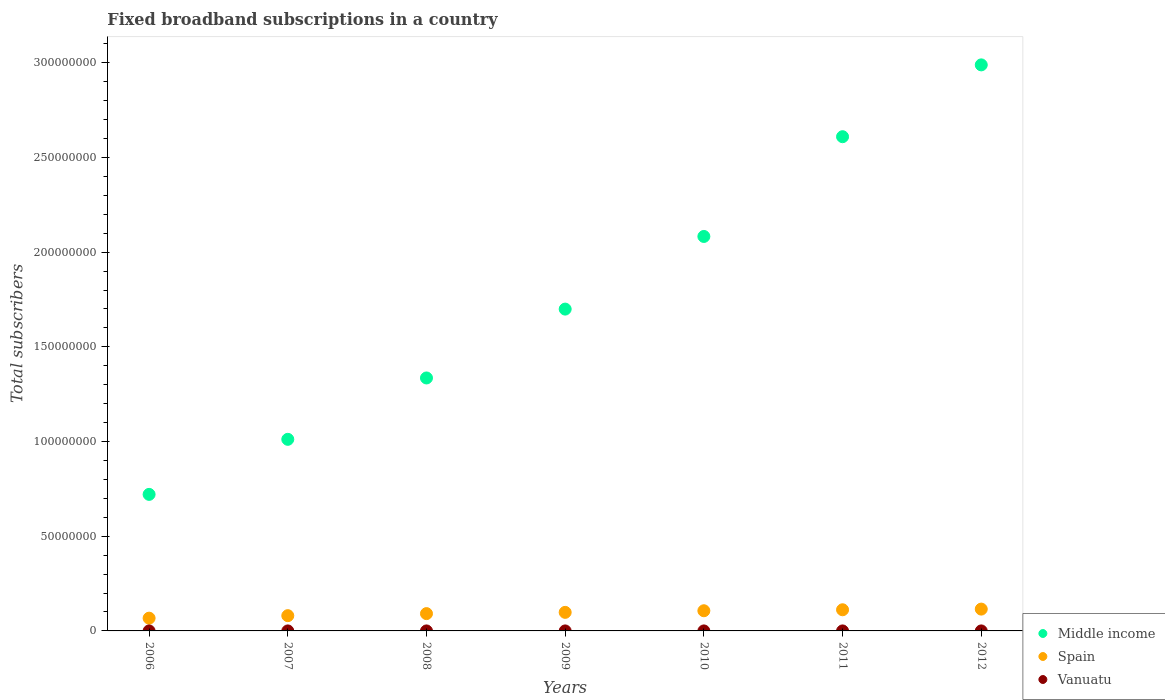How many different coloured dotlines are there?
Keep it short and to the point. 3. Is the number of dotlines equal to the number of legend labels?
Provide a succinct answer. Yes. What is the number of broadband subscriptions in Spain in 2010?
Your answer should be very brief. 1.07e+07. Across all years, what is the maximum number of broadband subscriptions in Middle income?
Make the answer very short. 2.99e+08. Across all years, what is the minimum number of broadband subscriptions in Spain?
Your answer should be compact. 6.74e+06. What is the total number of broadband subscriptions in Vanuatu in the graph?
Provide a succinct answer. 2072. What is the difference between the number of broadband subscriptions in Vanuatu in 2008 and that in 2009?
Give a very brief answer. -300. What is the difference between the number of broadband subscriptions in Spain in 2008 and the number of broadband subscriptions in Vanuatu in 2009?
Your response must be concise. 9.14e+06. What is the average number of broadband subscriptions in Vanuatu per year?
Ensure brevity in your answer.  296. In the year 2011, what is the difference between the number of broadband subscriptions in Spain and number of broadband subscriptions in Vanuatu?
Give a very brief answer. 1.12e+07. In how many years, is the number of broadband subscriptions in Middle income greater than 150000000?
Make the answer very short. 4. What is the ratio of the number of broadband subscriptions in Spain in 2006 to that in 2009?
Provide a succinct answer. 0.69. Is the number of broadband subscriptions in Middle income in 2007 less than that in 2009?
Offer a very short reply. Yes. Is the difference between the number of broadband subscriptions in Spain in 2008 and 2009 greater than the difference between the number of broadband subscriptions in Vanuatu in 2008 and 2009?
Your answer should be compact. No. What is the difference between the highest and the second highest number of broadband subscriptions in Vanuatu?
Make the answer very short. 0. What is the difference between the highest and the lowest number of broadband subscriptions in Middle income?
Keep it short and to the point. 2.27e+08. Is the sum of the number of broadband subscriptions in Vanuatu in 2007 and 2011 greater than the maximum number of broadband subscriptions in Middle income across all years?
Make the answer very short. No. Does the number of broadband subscriptions in Middle income monotonically increase over the years?
Your answer should be very brief. Yes. Is the number of broadband subscriptions in Middle income strictly greater than the number of broadband subscriptions in Spain over the years?
Your response must be concise. Yes. Is the number of broadband subscriptions in Spain strictly less than the number of broadband subscriptions in Middle income over the years?
Offer a terse response. Yes. Are the values on the major ticks of Y-axis written in scientific E-notation?
Your answer should be compact. No. Does the graph contain any zero values?
Your response must be concise. No. How are the legend labels stacked?
Offer a very short reply. Vertical. What is the title of the graph?
Provide a succinct answer. Fixed broadband subscriptions in a country. What is the label or title of the Y-axis?
Offer a terse response. Total subscribers. What is the Total subscribers in Middle income in 2006?
Keep it short and to the point. 7.21e+07. What is the Total subscribers in Spain in 2006?
Your answer should be compact. 6.74e+06. What is the Total subscribers in Vanuatu in 2006?
Keep it short and to the point. 95. What is the Total subscribers of Middle income in 2007?
Your answer should be very brief. 1.01e+08. What is the Total subscribers in Spain in 2007?
Your answer should be compact. 8.06e+06. What is the Total subscribers in Vanuatu in 2007?
Make the answer very short. 130. What is the Total subscribers of Middle income in 2008?
Your response must be concise. 1.34e+08. What is the Total subscribers in Spain in 2008?
Offer a terse response. 9.14e+06. What is the Total subscribers of Vanuatu in 2008?
Ensure brevity in your answer.  200. What is the Total subscribers in Middle income in 2009?
Keep it short and to the point. 1.70e+08. What is the Total subscribers in Spain in 2009?
Your answer should be compact. 9.80e+06. What is the Total subscribers in Middle income in 2010?
Offer a very short reply. 2.08e+08. What is the Total subscribers of Spain in 2010?
Provide a short and direct response. 1.07e+07. What is the Total subscribers in Middle income in 2011?
Offer a terse response. 2.61e+08. What is the Total subscribers of Spain in 2011?
Keep it short and to the point. 1.12e+07. What is the Total subscribers in Vanuatu in 2011?
Make the answer very short. 337. What is the Total subscribers of Middle income in 2012?
Offer a very short reply. 2.99e+08. What is the Total subscribers in Spain in 2012?
Offer a terse response. 1.15e+07. What is the Total subscribers in Vanuatu in 2012?
Offer a terse response. 310. Across all years, what is the maximum Total subscribers of Middle income?
Make the answer very short. 2.99e+08. Across all years, what is the maximum Total subscribers of Spain?
Your response must be concise. 1.15e+07. Across all years, what is the maximum Total subscribers of Vanuatu?
Offer a terse response. 500. Across all years, what is the minimum Total subscribers of Middle income?
Keep it short and to the point. 7.21e+07. Across all years, what is the minimum Total subscribers in Spain?
Ensure brevity in your answer.  6.74e+06. What is the total Total subscribers in Middle income in the graph?
Provide a short and direct response. 1.24e+09. What is the total Total subscribers in Spain in the graph?
Your response must be concise. 6.71e+07. What is the total Total subscribers of Vanuatu in the graph?
Offer a very short reply. 2072. What is the difference between the Total subscribers in Middle income in 2006 and that in 2007?
Offer a terse response. -2.91e+07. What is the difference between the Total subscribers in Spain in 2006 and that in 2007?
Keep it short and to the point. -1.32e+06. What is the difference between the Total subscribers of Vanuatu in 2006 and that in 2007?
Your answer should be very brief. -35. What is the difference between the Total subscribers in Middle income in 2006 and that in 2008?
Ensure brevity in your answer.  -6.15e+07. What is the difference between the Total subscribers of Spain in 2006 and that in 2008?
Your answer should be very brief. -2.40e+06. What is the difference between the Total subscribers of Vanuatu in 2006 and that in 2008?
Make the answer very short. -105. What is the difference between the Total subscribers of Middle income in 2006 and that in 2009?
Keep it short and to the point. -9.78e+07. What is the difference between the Total subscribers of Spain in 2006 and that in 2009?
Provide a succinct answer. -3.06e+06. What is the difference between the Total subscribers of Vanuatu in 2006 and that in 2009?
Offer a very short reply. -405. What is the difference between the Total subscribers in Middle income in 2006 and that in 2010?
Your answer should be compact. -1.36e+08. What is the difference between the Total subscribers in Spain in 2006 and that in 2010?
Make the answer very short. -3.91e+06. What is the difference between the Total subscribers in Vanuatu in 2006 and that in 2010?
Give a very brief answer. -405. What is the difference between the Total subscribers of Middle income in 2006 and that in 2011?
Keep it short and to the point. -1.89e+08. What is the difference between the Total subscribers of Spain in 2006 and that in 2011?
Your answer should be compact. -4.43e+06. What is the difference between the Total subscribers of Vanuatu in 2006 and that in 2011?
Your response must be concise. -242. What is the difference between the Total subscribers of Middle income in 2006 and that in 2012?
Your response must be concise. -2.27e+08. What is the difference between the Total subscribers in Spain in 2006 and that in 2012?
Offer a very short reply. -4.79e+06. What is the difference between the Total subscribers in Vanuatu in 2006 and that in 2012?
Offer a very short reply. -215. What is the difference between the Total subscribers in Middle income in 2007 and that in 2008?
Make the answer very short. -3.24e+07. What is the difference between the Total subscribers of Spain in 2007 and that in 2008?
Your response must be concise. -1.08e+06. What is the difference between the Total subscribers of Vanuatu in 2007 and that in 2008?
Your answer should be compact. -70. What is the difference between the Total subscribers of Middle income in 2007 and that in 2009?
Offer a very short reply. -6.88e+07. What is the difference between the Total subscribers of Spain in 2007 and that in 2009?
Provide a short and direct response. -1.74e+06. What is the difference between the Total subscribers of Vanuatu in 2007 and that in 2009?
Offer a very short reply. -370. What is the difference between the Total subscribers of Middle income in 2007 and that in 2010?
Provide a succinct answer. -1.07e+08. What is the difference between the Total subscribers of Spain in 2007 and that in 2010?
Provide a short and direct response. -2.60e+06. What is the difference between the Total subscribers in Vanuatu in 2007 and that in 2010?
Your answer should be very brief. -370. What is the difference between the Total subscribers of Middle income in 2007 and that in 2011?
Ensure brevity in your answer.  -1.60e+08. What is the difference between the Total subscribers of Spain in 2007 and that in 2011?
Provide a short and direct response. -3.11e+06. What is the difference between the Total subscribers in Vanuatu in 2007 and that in 2011?
Make the answer very short. -207. What is the difference between the Total subscribers in Middle income in 2007 and that in 2012?
Offer a very short reply. -1.98e+08. What is the difference between the Total subscribers in Spain in 2007 and that in 2012?
Your response must be concise. -3.47e+06. What is the difference between the Total subscribers in Vanuatu in 2007 and that in 2012?
Offer a terse response. -180. What is the difference between the Total subscribers of Middle income in 2008 and that in 2009?
Give a very brief answer. -3.64e+07. What is the difference between the Total subscribers of Spain in 2008 and that in 2009?
Offer a terse response. -6.65e+05. What is the difference between the Total subscribers in Vanuatu in 2008 and that in 2009?
Your response must be concise. -300. What is the difference between the Total subscribers of Middle income in 2008 and that in 2010?
Offer a terse response. -7.47e+07. What is the difference between the Total subscribers of Spain in 2008 and that in 2010?
Keep it short and to the point. -1.52e+06. What is the difference between the Total subscribers of Vanuatu in 2008 and that in 2010?
Your answer should be compact. -300. What is the difference between the Total subscribers in Middle income in 2008 and that in 2011?
Keep it short and to the point. -1.27e+08. What is the difference between the Total subscribers in Spain in 2008 and that in 2011?
Your answer should be compact. -2.03e+06. What is the difference between the Total subscribers in Vanuatu in 2008 and that in 2011?
Offer a terse response. -137. What is the difference between the Total subscribers of Middle income in 2008 and that in 2012?
Your response must be concise. -1.65e+08. What is the difference between the Total subscribers of Spain in 2008 and that in 2012?
Make the answer very short. -2.39e+06. What is the difference between the Total subscribers in Vanuatu in 2008 and that in 2012?
Ensure brevity in your answer.  -110. What is the difference between the Total subscribers of Middle income in 2009 and that in 2010?
Your answer should be compact. -3.84e+07. What is the difference between the Total subscribers of Spain in 2009 and that in 2010?
Give a very brief answer. -8.52e+05. What is the difference between the Total subscribers in Middle income in 2009 and that in 2011?
Offer a terse response. -9.10e+07. What is the difference between the Total subscribers in Spain in 2009 and that in 2011?
Your response must be concise. -1.37e+06. What is the difference between the Total subscribers in Vanuatu in 2009 and that in 2011?
Make the answer very short. 163. What is the difference between the Total subscribers in Middle income in 2009 and that in 2012?
Make the answer very short. -1.29e+08. What is the difference between the Total subscribers in Spain in 2009 and that in 2012?
Provide a succinct answer. -1.72e+06. What is the difference between the Total subscribers of Vanuatu in 2009 and that in 2012?
Provide a short and direct response. 190. What is the difference between the Total subscribers in Middle income in 2010 and that in 2011?
Your answer should be compact. -5.27e+07. What is the difference between the Total subscribers of Spain in 2010 and that in 2011?
Provide a succinct answer. -5.15e+05. What is the difference between the Total subscribers of Vanuatu in 2010 and that in 2011?
Your response must be concise. 163. What is the difference between the Total subscribers in Middle income in 2010 and that in 2012?
Give a very brief answer. -9.06e+07. What is the difference between the Total subscribers in Spain in 2010 and that in 2012?
Offer a very short reply. -8.72e+05. What is the difference between the Total subscribers of Vanuatu in 2010 and that in 2012?
Offer a terse response. 190. What is the difference between the Total subscribers of Middle income in 2011 and that in 2012?
Provide a short and direct response. -3.79e+07. What is the difference between the Total subscribers of Spain in 2011 and that in 2012?
Your answer should be compact. -3.57e+05. What is the difference between the Total subscribers of Vanuatu in 2011 and that in 2012?
Your answer should be compact. 27. What is the difference between the Total subscribers of Middle income in 2006 and the Total subscribers of Spain in 2007?
Ensure brevity in your answer.  6.40e+07. What is the difference between the Total subscribers in Middle income in 2006 and the Total subscribers in Vanuatu in 2007?
Offer a terse response. 7.21e+07. What is the difference between the Total subscribers in Spain in 2006 and the Total subscribers in Vanuatu in 2007?
Your answer should be very brief. 6.74e+06. What is the difference between the Total subscribers of Middle income in 2006 and the Total subscribers of Spain in 2008?
Your answer should be very brief. 6.30e+07. What is the difference between the Total subscribers of Middle income in 2006 and the Total subscribers of Vanuatu in 2008?
Provide a short and direct response. 7.21e+07. What is the difference between the Total subscribers of Spain in 2006 and the Total subscribers of Vanuatu in 2008?
Your response must be concise. 6.74e+06. What is the difference between the Total subscribers of Middle income in 2006 and the Total subscribers of Spain in 2009?
Your response must be concise. 6.23e+07. What is the difference between the Total subscribers of Middle income in 2006 and the Total subscribers of Vanuatu in 2009?
Give a very brief answer. 7.21e+07. What is the difference between the Total subscribers in Spain in 2006 and the Total subscribers in Vanuatu in 2009?
Keep it short and to the point. 6.74e+06. What is the difference between the Total subscribers of Middle income in 2006 and the Total subscribers of Spain in 2010?
Provide a succinct answer. 6.14e+07. What is the difference between the Total subscribers in Middle income in 2006 and the Total subscribers in Vanuatu in 2010?
Give a very brief answer. 7.21e+07. What is the difference between the Total subscribers in Spain in 2006 and the Total subscribers in Vanuatu in 2010?
Ensure brevity in your answer.  6.74e+06. What is the difference between the Total subscribers in Middle income in 2006 and the Total subscribers in Spain in 2011?
Give a very brief answer. 6.09e+07. What is the difference between the Total subscribers in Middle income in 2006 and the Total subscribers in Vanuatu in 2011?
Provide a succinct answer. 7.21e+07. What is the difference between the Total subscribers in Spain in 2006 and the Total subscribers in Vanuatu in 2011?
Keep it short and to the point. 6.74e+06. What is the difference between the Total subscribers in Middle income in 2006 and the Total subscribers in Spain in 2012?
Your answer should be compact. 6.06e+07. What is the difference between the Total subscribers of Middle income in 2006 and the Total subscribers of Vanuatu in 2012?
Your answer should be compact. 7.21e+07. What is the difference between the Total subscribers in Spain in 2006 and the Total subscribers in Vanuatu in 2012?
Your response must be concise. 6.74e+06. What is the difference between the Total subscribers in Middle income in 2007 and the Total subscribers in Spain in 2008?
Make the answer very short. 9.20e+07. What is the difference between the Total subscribers in Middle income in 2007 and the Total subscribers in Vanuatu in 2008?
Offer a terse response. 1.01e+08. What is the difference between the Total subscribers in Spain in 2007 and the Total subscribers in Vanuatu in 2008?
Your answer should be compact. 8.06e+06. What is the difference between the Total subscribers of Middle income in 2007 and the Total subscribers of Spain in 2009?
Offer a terse response. 9.14e+07. What is the difference between the Total subscribers of Middle income in 2007 and the Total subscribers of Vanuatu in 2009?
Your answer should be compact. 1.01e+08. What is the difference between the Total subscribers in Spain in 2007 and the Total subscribers in Vanuatu in 2009?
Ensure brevity in your answer.  8.06e+06. What is the difference between the Total subscribers of Middle income in 2007 and the Total subscribers of Spain in 2010?
Make the answer very short. 9.05e+07. What is the difference between the Total subscribers in Middle income in 2007 and the Total subscribers in Vanuatu in 2010?
Provide a short and direct response. 1.01e+08. What is the difference between the Total subscribers of Spain in 2007 and the Total subscribers of Vanuatu in 2010?
Ensure brevity in your answer.  8.06e+06. What is the difference between the Total subscribers of Middle income in 2007 and the Total subscribers of Spain in 2011?
Your answer should be compact. 9.00e+07. What is the difference between the Total subscribers in Middle income in 2007 and the Total subscribers in Vanuatu in 2011?
Keep it short and to the point. 1.01e+08. What is the difference between the Total subscribers of Spain in 2007 and the Total subscribers of Vanuatu in 2011?
Your answer should be very brief. 8.06e+06. What is the difference between the Total subscribers of Middle income in 2007 and the Total subscribers of Spain in 2012?
Offer a terse response. 8.96e+07. What is the difference between the Total subscribers of Middle income in 2007 and the Total subscribers of Vanuatu in 2012?
Your answer should be compact. 1.01e+08. What is the difference between the Total subscribers of Spain in 2007 and the Total subscribers of Vanuatu in 2012?
Provide a short and direct response. 8.06e+06. What is the difference between the Total subscribers of Middle income in 2008 and the Total subscribers of Spain in 2009?
Offer a terse response. 1.24e+08. What is the difference between the Total subscribers in Middle income in 2008 and the Total subscribers in Vanuatu in 2009?
Ensure brevity in your answer.  1.34e+08. What is the difference between the Total subscribers in Spain in 2008 and the Total subscribers in Vanuatu in 2009?
Ensure brevity in your answer.  9.14e+06. What is the difference between the Total subscribers in Middle income in 2008 and the Total subscribers in Spain in 2010?
Give a very brief answer. 1.23e+08. What is the difference between the Total subscribers in Middle income in 2008 and the Total subscribers in Vanuatu in 2010?
Give a very brief answer. 1.34e+08. What is the difference between the Total subscribers of Spain in 2008 and the Total subscribers of Vanuatu in 2010?
Offer a terse response. 9.14e+06. What is the difference between the Total subscribers of Middle income in 2008 and the Total subscribers of Spain in 2011?
Provide a succinct answer. 1.22e+08. What is the difference between the Total subscribers of Middle income in 2008 and the Total subscribers of Vanuatu in 2011?
Offer a terse response. 1.34e+08. What is the difference between the Total subscribers of Spain in 2008 and the Total subscribers of Vanuatu in 2011?
Your answer should be very brief. 9.14e+06. What is the difference between the Total subscribers in Middle income in 2008 and the Total subscribers in Spain in 2012?
Give a very brief answer. 1.22e+08. What is the difference between the Total subscribers of Middle income in 2008 and the Total subscribers of Vanuatu in 2012?
Offer a terse response. 1.34e+08. What is the difference between the Total subscribers in Spain in 2008 and the Total subscribers in Vanuatu in 2012?
Your answer should be very brief. 9.14e+06. What is the difference between the Total subscribers in Middle income in 2009 and the Total subscribers in Spain in 2010?
Make the answer very short. 1.59e+08. What is the difference between the Total subscribers of Middle income in 2009 and the Total subscribers of Vanuatu in 2010?
Ensure brevity in your answer.  1.70e+08. What is the difference between the Total subscribers of Spain in 2009 and the Total subscribers of Vanuatu in 2010?
Your answer should be very brief. 9.80e+06. What is the difference between the Total subscribers of Middle income in 2009 and the Total subscribers of Spain in 2011?
Your answer should be very brief. 1.59e+08. What is the difference between the Total subscribers of Middle income in 2009 and the Total subscribers of Vanuatu in 2011?
Offer a terse response. 1.70e+08. What is the difference between the Total subscribers in Spain in 2009 and the Total subscribers in Vanuatu in 2011?
Your response must be concise. 9.80e+06. What is the difference between the Total subscribers in Middle income in 2009 and the Total subscribers in Spain in 2012?
Offer a very short reply. 1.58e+08. What is the difference between the Total subscribers of Middle income in 2009 and the Total subscribers of Vanuatu in 2012?
Offer a very short reply. 1.70e+08. What is the difference between the Total subscribers in Spain in 2009 and the Total subscribers in Vanuatu in 2012?
Your answer should be compact. 9.80e+06. What is the difference between the Total subscribers in Middle income in 2010 and the Total subscribers in Spain in 2011?
Offer a terse response. 1.97e+08. What is the difference between the Total subscribers in Middle income in 2010 and the Total subscribers in Vanuatu in 2011?
Offer a very short reply. 2.08e+08. What is the difference between the Total subscribers of Spain in 2010 and the Total subscribers of Vanuatu in 2011?
Your answer should be very brief. 1.07e+07. What is the difference between the Total subscribers in Middle income in 2010 and the Total subscribers in Spain in 2012?
Your answer should be compact. 1.97e+08. What is the difference between the Total subscribers of Middle income in 2010 and the Total subscribers of Vanuatu in 2012?
Provide a short and direct response. 2.08e+08. What is the difference between the Total subscribers in Spain in 2010 and the Total subscribers in Vanuatu in 2012?
Your answer should be compact. 1.07e+07. What is the difference between the Total subscribers of Middle income in 2011 and the Total subscribers of Spain in 2012?
Your answer should be compact. 2.49e+08. What is the difference between the Total subscribers of Middle income in 2011 and the Total subscribers of Vanuatu in 2012?
Your answer should be compact. 2.61e+08. What is the difference between the Total subscribers in Spain in 2011 and the Total subscribers in Vanuatu in 2012?
Provide a short and direct response. 1.12e+07. What is the average Total subscribers of Middle income per year?
Provide a succinct answer. 1.78e+08. What is the average Total subscribers in Spain per year?
Your answer should be compact. 9.58e+06. What is the average Total subscribers in Vanuatu per year?
Your response must be concise. 296. In the year 2006, what is the difference between the Total subscribers of Middle income and Total subscribers of Spain?
Provide a succinct answer. 6.54e+07. In the year 2006, what is the difference between the Total subscribers in Middle income and Total subscribers in Vanuatu?
Give a very brief answer. 7.21e+07. In the year 2006, what is the difference between the Total subscribers in Spain and Total subscribers in Vanuatu?
Offer a terse response. 6.74e+06. In the year 2007, what is the difference between the Total subscribers of Middle income and Total subscribers of Spain?
Keep it short and to the point. 9.31e+07. In the year 2007, what is the difference between the Total subscribers in Middle income and Total subscribers in Vanuatu?
Keep it short and to the point. 1.01e+08. In the year 2007, what is the difference between the Total subscribers in Spain and Total subscribers in Vanuatu?
Provide a succinct answer. 8.06e+06. In the year 2008, what is the difference between the Total subscribers of Middle income and Total subscribers of Spain?
Offer a very short reply. 1.24e+08. In the year 2008, what is the difference between the Total subscribers of Middle income and Total subscribers of Vanuatu?
Keep it short and to the point. 1.34e+08. In the year 2008, what is the difference between the Total subscribers of Spain and Total subscribers of Vanuatu?
Make the answer very short. 9.14e+06. In the year 2009, what is the difference between the Total subscribers in Middle income and Total subscribers in Spain?
Offer a terse response. 1.60e+08. In the year 2009, what is the difference between the Total subscribers of Middle income and Total subscribers of Vanuatu?
Keep it short and to the point. 1.70e+08. In the year 2009, what is the difference between the Total subscribers in Spain and Total subscribers in Vanuatu?
Your response must be concise. 9.80e+06. In the year 2010, what is the difference between the Total subscribers in Middle income and Total subscribers in Spain?
Ensure brevity in your answer.  1.98e+08. In the year 2010, what is the difference between the Total subscribers in Middle income and Total subscribers in Vanuatu?
Make the answer very short. 2.08e+08. In the year 2010, what is the difference between the Total subscribers in Spain and Total subscribers in Vanuatu?
Make the answer very short. 1.07e+07. In the year 2011, what is the difference between the Total subscribers of Middle income and Total subscribers of Spain?
Ensure brevity in your answer.  2.50e+08. In the year 2011, what is the difference between the Total subscribers in Middle income and Total subscribers in Vanuatu?
Keep it short and to the point. 2.61e+08. In the year 2011, what is the difference between the Total subscribers in Spain and Total subscribers in Vanuatu?
Give a very brief answer. 1.12e+07. In the year 2012, what is the difference between the Total subscribers in Middle income and Total subscribers in Spain?
Keep it short and to the point. 2.87e+08. In the year 2012, what is the difference between the Total subscribers of Middle income and Total subscribers of Vanuatu?
Provide a succinct answer. 2.99e+08. In the year 2012, what is the difference between the Total subscribers in Spain and Total subscribers in Vanuatu?
Ensure brevity in your answer.  1.15e+07. What is the ratio of the Total subscribers in Middle income in 2006 to that in 2007?
Offer a very short reply. 0.71. What is the ratio of the Total subscribers of Spain in 2006 to that in 2007?
Offer a terse response. 0.84. What is the ratio of the Total subscribers of Vanuatu in 2006 to that in 2007?
Your answer should be compact. 0.73. What is the ratio of the Total subscribers of Middle income in 2006 to that in 2008?
Your answer should be compact. 0.54. What is the ratio of the Total subscribers of Spain in 2006 to that in 2008?
Provide a short and direct response. 0.74. What is the ratio of the Total subscribers of Vanuatu in 2006 to that in 2008?
Ensure brevity in your answer.  0.47. What is the ratio of the Total subscribers of Middle income in 2006 to that in 2009?
Provide a succinct answer. 0.42. What is the ratio of the Total subscribers of Spain in 2006 to that in 2009?
Your answer should be very brief. 0.69. What is the ratio of the Total subscribers of Vanuatu in 2006 to that in 2009?
Offer a very short reply. 0.19. What is the ratio of the Total subscribers of Middle income in 2006 to that in 2010?
Offer a terse response. 0.35. What is the ratio of the Total subscribers of Spain in 2006 to that in 2010?
Offer a very short reply. 0.63. What is the ratio of the Total subscribers of Vanuatu in 2006 to that in 2010?
Your response must be concise. 0.19. What is the ratio of the Total subscribers of Middle income in 2006 to that in 2011?
Give a very brief answer. 0.28. What is the ratio of the Total subscribers in Spain in 2006 to that in 2011?
Offer a very short reply. 0.6. What is the ratio of the Total subscribers of Vanuatu in 2006 to that in 2011?
Your answer should be compact. 0.28. What is the ratio of the Total subscribers in Middle income in 2006 to that in 2012?
Keep it short and to the point. 0.24. What is the ratio of the Total subscribers in Spain in 2006 to that in 2012?
Keep it short and to the point. 0.58. What is the ratio of the Total subscribers in Vanuatu in 2006 to that in 2012?
Give a very brief answer. 0.31. What is the ratio of the Total subscribers in Middle income in 2007 to that in 2008?
Keep it short and to the point. 0.76. What is the ratio of the Total subscribers in Spain in 2007 to that in 2008?
Provide a short and direct response. 0.88. What is the ratio of the Total subscribers in Vanuatu in 2007 to that in 2008?
Offer a very short reply. 0.65. What is the ratio of the Total subscribers of Middle income in 2007 to that in 2009?
Ensure brevity in your answer.  0.6. What is the ratio of the Total subscribers of Spain in 2007 to that in 2009?
Offer a very short reply. 0.82. What is the ratio of the Total subscribers of Vanuatu in 2007 to that in 2009?
Provide a short and direct response. 0.26. What is the ratio of the Total subscribers in Middle income in 2007 to that in 2010?
Provide a succinct answer. 0.49. What is the ratio of the Total subscribers of Spain in 2007 to that in 2010?
Your answer should be very brief. 0.76. What is the ratio of the Total subscribers of Vanuatu in 2007 to that in 2010?
Offer a terse response. 0.26. What is the ratio of the Total subscribers in Middle income in 2007 to that in 2011?
Provide a short and direct response. 0.39. What is the ratio of the Total subscribers in Spain in 2007 to that in 2011?
Make the answer very short. 0.72. What is the ratio of the Total subscribers of Vanuatu in 2007 to that in 2011?
Provide a succinct answer. 0.39. What is the ratio of the Total subscribers in Middle income in 2007 to that in 2012?
Keep it short and to the point. 0.34. What is the ratio of the Total subscribers in Spain in 2007 to that in 2012?
Make the answer very short. 0.7. What is the ratio of the Total subscribers in Vanuatu in 2007 to that in 2012?
Offer a terse response. 0.42. What is the ratio of the Total subscribers of Middle income in 2008 to that in 2009?
Ensure brevity in your answer.  0.79. What is the ratio of the Total subscribers of Spain in 2008 to that in 2009?
Keep it short and to the point. 0.93. What is the ratio of the Total subscribers of Vanuatu in 2008 to that in 2009?
Provide a succinct answer. 0.4. What is the ratio of the Total subscribers of Middle income in 2008 to that in 2010?
Ensure brevity in your answer.  0.64. What is the ratio of the Total subscribers of Spain in 2008 to that in 2010?
Your answer should be compact. 0.86. What is the ratio of the Total subscribers of Middle income in 2008 to that in 2011?
Offer a terse response. 0.51. What is the ratio of the Total subscribers of Spain in 2008 to that in 2011?
Provide a short and direct response. 0.82. What is the ratio of the Total subscribers in Vanuatu in 2008 to that in 2011?
Make the answer very short. 0.59. What is the ratio of the Total subscribers in Middle income in 2008 to that in 2012?
Provide a short and direct response. 0.45. What is the ratio of the Total subscribers of Spain in 2008 to that in 2012?
Offer a very short reply. 0.79. What is the ratio of the Total subscribers in Vanuatu in 2008 to that in 2012?
Ensure brevity in your answer.  0.65. What is the ratio of the Total subscribers of Middle income in 2009 to that in 2010?
Offer a very short reply. 0.82. What is the ratio of the Total subscribers of Spain in 2009 to that in 2010?
Provide a succinct answer. 0.92. What is the ratio of the Total subscribers of Middle income in 2009 to that in 2011?
Offer a very short reply. 0.65. What is the ratio of the Total subscribers in Spain in 2009 to that in 2011?
Make the answer very short. 0.88. What is the ratio of the Total subscribers of Vanuatu in 2009 to that in 2011?
Keep it short and to the point. 1.48. What is the ratio of the Total subscribers in Middle income in 2009 to that in 2012?
Keep it short and to the point. 0.57. What is the ratio of the Total subscribers of Spain in 2009 to that in 2012?
Provide a succinct answer. 0.85. What is the ratio of the Total subscribers of Vanuatu in 2009 to that in 2012?
Offer a very short reply. 1.61. What is the ratio of the Total subscribers of Middle income in 2010 to that in 2011?
Keep it short and to the point. 0.8. What is the ratio of the Total subscribers of Spain in 2010 to that in 2011?
Your response must be concise. 0.95. What is the ratio of the Total subscribers in Vanuatu in 2010 to that in 2011?
Keep it short and to the point. 1.48. What is the ratio of the Total subscribers of Middle income in 2010 to that in 2012?
Offer a terse response. 0.7. What is the ratio of the Total subscribers of Spain in 2010 to that in 2012?
Your response must be concise. 0.92. What is the ratio of the Total subscribers of Vanuatu in 2010 to that in 2012?
Keep it short and to the point. 1.61. What is the ratio of the Total subscribers in Middle income in 2011 to that in 2012?
Keep it short and to the point. 0.87. What is the ratio of the Total subscribers of Vanuatu in 2011 to that in 2012?
Keep it short and to the point. 1.09. What is the difference between the highest and the second highest Total subscribers of Middle income?
Keep it short and to the point. 3.79e+07. What is the difference between the highest and the second highest Total subscribers in Spain?
Offer a terse response. 3.57e+05. What is the difference between the highest and the second highest Total subscribers in Vanuatu?
Provide a short and direct response. 0. What is the difference between the highest and the lowest Total subscribers of Middle income?
Offer a very short reply. 2.27e+08. What is the difference between the highest and the lowest Total subscribers of Spain?
Make the answer very short. 4.79e+06. What is the difference between the highest and the lowest Total subscribers in Vanuatu?
Make the answer very short. 405. 